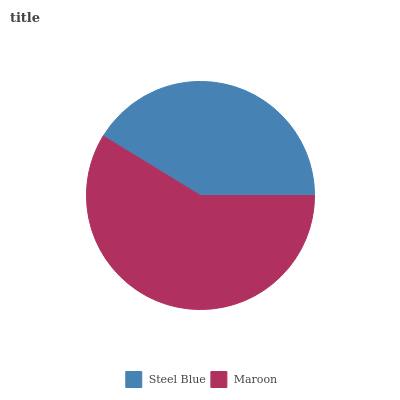Is Steel Blue the minimum?
Answer yes or no. Yes. Is Maroon the maximum?
Answer yes or no. Yes. Is Maroon the minimum?
Answer yes or no. No. Is Maroon greater than Steel Blue?
Answer yes or no. Yes. Is Steel Blue less than Maroon?
Answer yes or no. Yes. Is Steel Blue greater than Maroon?
Answer yes or no. No. Is Maroon less than Steel Blue?
Answer yes or no. No. Is Maroon the high median?
Answer yes or no. Yes. Is Steel Blue the low median?
Answer yes or no. Yes. Is Steel Blue the high median?
Answer yes or no. No. Is Maroon the low median?
Answer yes or no. No. 